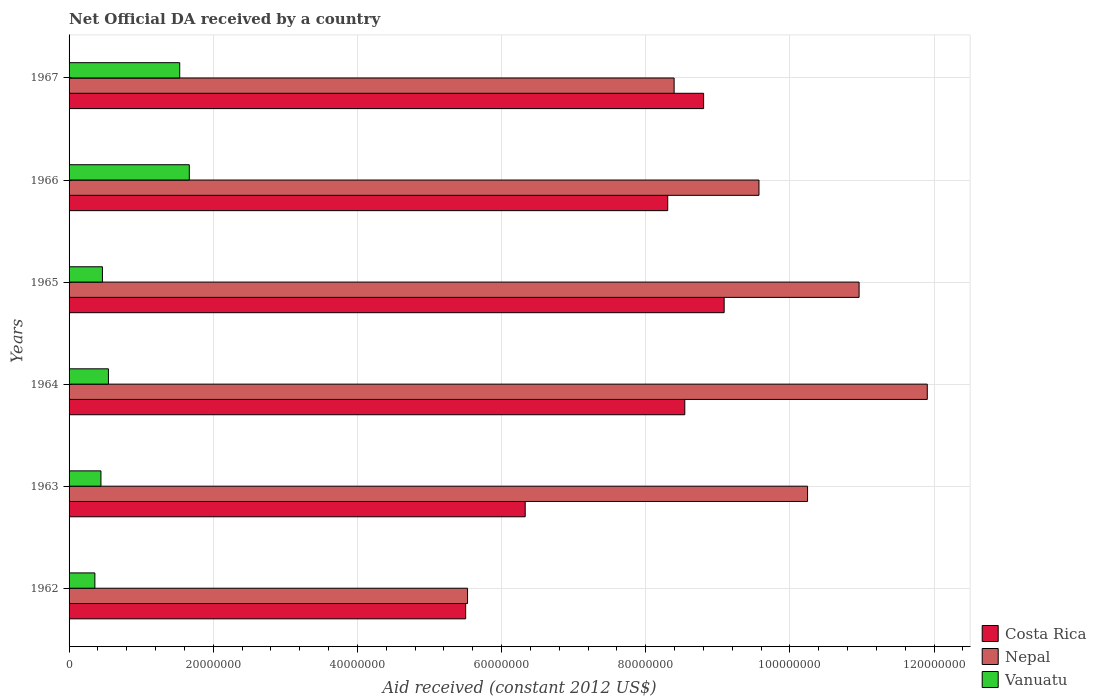How many groups of bars are there?
Your answer should be very brief. 6. What is the label of the 2nd group of bars from the top?
Offer a terse response. 1966. What is the net official development assistance aid received in Nepal in 1964?
Your response must be concise. 1.19e+08. Across all years, what is the maximum net official development assistance aid received in Nepal?
Provide a short and direct response. 1.19e+08. Across all years, what is the minimum net official development assistance aid received in Vanuatu?
Provide a succinct answer. 3.58e+06. In which year was the net official development assistance aid received in Nepal maximum?
Keep it short and to the point. 1964. In which year was the net official development assistance aid received in Nepal minimum?
Your response must be concise. 1962. What is the total net official development assistance aid received in Vanuatu in the graph?
Provide a short and direct response. 5.01e+07. What is the difference between the net official development assistance aid received in Costa Rica in 1964 and that in 1966?
Provide a succinct answer. 2.37e+06. What is the difference between the net official development assistance aid received in Nepal in 1962 and the net official development assistance aid received in Costa Rica in 1963?
Keep it short and to the point. -8.00e+06. What is the average net official development assistance aid received in Nepal per year?
Provide a succinct answer. 9.43e+07. In the year 1964, what is the difference between the net official development assistance aid received in Nepal and net official development assistance aid received in Vanuatu?
Offer a terse response. 1.14e+08. What is the ratio of the net official development assistance aid received in Nepal in 1962 to that in 1964?
Provide a succinct answer. 0.46. What is the difference between the highest and the second highest net official development assistance aid received in Vanuatu?
Provide a short and direct response. 1.33e+06. What is the difference between the highest and the lowest net official development assistance aid received in Nepal?
Your answer should be very brief. 6.38e+07. In how many years, is the net official development assistance aid received in Vanuatu greater than the average net official development assistance aid received in Vanuatu taken over all years?
Your answer should be compact. 2. What does the 3rd bar from the top in 1962 represents?
Your answer should be compact. Costa Rica. What does the 2nd bar from the bottom in 1965 represents?
Ensure brevity in your answer.  Nepal. Is it the case that in every year, the sum of the net official development assistance aid received in Vanuatu and net official development assistance aid received in Nepal is greater than the net official development assistance aid received in Costa Rica?
Provide a short and direct response. Yes. How many bars are there?
Ensure brevity in your answer.  18. Are the values on the major ticks of X-axis written in scientific E-notation?
Provide a succinct answer. No. Where does the legend appear in the graph?
Keep it short and to the point. Bottom right. How are the legend labels stacked?
Your answer should be very brief. Vertical. What is the title of the graph?
Offer a terse response. Net Official DA received by a country. What is the label or title of the X-axis?
Give a very brief answer. Aid received (constant 2012 US$). What is the label or title of the Y-axis?
Offer a terse response. Years. What is the Aid received (constant 2012 US$) in Costa Rica in 1962?
Offer a terse response. 5.50e+07. What is the Aid received (constant 2012 US$) in Nepal in 1962?
Your response must be concise. 5.53e+07. What is the Aid received (constant 2012 US$) in Vanuatu in 1962?
Your answer should be compact. 3.58e+06. What is the Aid received (constant 2012 US$) in Costa Rica in 1963?
Your answer should be compact. 6.33e+07. What is the Aid received (constant 2012 US$) of Nepal in 1963?
Provide a succinct answer. 1.02e+08. What is the Aid received (constant 2012 US$) of Vanuatu in 1963?
Keep it short and to the point. 4.42e+06. What is the Aid received (constant 2012 US$) in Costa Rica in 1964?
Keep it short and to the point. 8.54e+07. What is the Aid received (constant 2012 US$) in Nepal in 1964?
Keep it short and to the point. 1.19e+08. What is the Aid received (constant 2012 US$) of Vanuatu in 1964?
Make the answer very short. 5.46e+06. What is the Aid received (constant 2012 US$) in Costa Rica in 1965?
Ensure brevity in your answer.  9.09e+07. What is the Aid received (constant 2012 US$) of Nepal in 1965?
Keep it short and to the point. 1.10e+08. What is the Aid received (constant 2012 US$) in Vanuatu in 1965?
Offer a terse response. 4.63e+06. What is the Aid received (constant 2012 US$) in Costa Rica in 1966?
Make the answer very short. 8.30e+07. What is the Aid received (constant 2012 US$) of Nepal in 1966?
Offer a terse response. 9.57e+07. What is the Aid received (constant 2012 US$) in Vanuatu in 1966?
Offer a very short reply. 1.67e+07. What is the Aid received (constant 2012 US$) in Costa Rica in 1967?
Your answer should be compact. 8.80e+07. What is the Aid received (constant 2012 US$) in Nepal in 1967?
Offer a very short reply. 8.39e+07. What is the Aid received (constant 2012 US$) of Vanuatu in 1967?
Provide a succinct answer. 1.54e+07. Across all years, what is the maximum Aid received (constant 2012 US$) in Costa Rica?
Your response must be concise. 9.09e+07. Across all years, what is the maximum Aid received (constant 2012 US$) in Nepal?
Offer a very short reply. 1.19e+08. Across all years, what is the maximum Aid received (constant 2012 US$) of Vanuatu?
Offer a terse response. 1.67e+07. Across all years, what is the minimum Aid received (constant 2012 US$) of Costa Rica?
Provide a short and direct response. 5.50e+07. Across all years, what is the minimum Aid received (constant 2012 US$) in Nepal?
Give a very brief answer. 5.53e+07. Across all years, what is the minimum Aid received (constant 2012 US$) in Vanuatu?
Ensure brevity in your answer.  3.58e+06. What is the total Aid received (constant 2012 US$) of Costa Rica in the graph?
Give a very brief answer. 4.66e+08. What is the total Aid received (constant 2012 US$) of Nepal in the graph?
Provide a succinct answer. 5.66e+08. What is the total Aid received (constant 2012 US$) of Vanuatu in the graph?
Your response must be concise. 5.01e+07. What is the difference between the Aid received (constant 2012 US$) in Costa Rica in 1962 and that in 1963?
Make the answer very short. -8.26e+06. What is the difference between the Aid received (constant 2012 US$) in Nepal in 1962 and that in 1963?
Provide a short and direct response. -4.72e+07. What is the difference between the Aid received (constant 2012 US$) of Vanuatu in 1962 and that in 1963?
Your response must be concise. -8.40e+05. What is the difference between the Aid received (constant 2012 US$) of Costa Rica in 1962 and that in 1964?
Keep it short and to the point. -3.04e+07. What is the difference between the Aid received (constant 2012 US$) in Nepal in 1962 and that in 1964?
Your answer should be very brief. -6.38e+07. What is the difference between the Aid received (constant 2012 US$) of Vanuatu in 1962 and that in 1964?
Your answer should be very brief. -1.88e+06. What is the difference between the Aid received (constant 2012 US$) of Costa Rica in 1962 and that in 1965?
Keep it short and to the point. -3.59e+07. What is the difference between the Aid received (constant 2012 US$) of Nepal in 1962 and that in 1965?
Ensure brevity in your answer.  -5.43e+07. What is the difference between the Aid received (constant 2012 US$) in Vanuatu in 1962 and that in 1965?
Give a very brief answer. -1.05e+06. What is the difference between the Aid received (constant 2012 US$) in Costa Rica in 1962 and that in 1966?
Your answer should be very brief. -2.80e+07. What is the difference between the Aid received (constant 2012 US$) in Nepal in 1962 and that in 1966?
Ensure brevity in your answer.  -4.04e+07. What is the difference between the Aid received (constant 2012 US$) of Vanuatu in 1962 and that in 1966?
Offer a very short reply. -1.31e+07. What is the difference between the Aid received (constant 2012 US$) in Costa Rica in 1962 and that in 1967?
Your answer should be compact. -3.30e+07. What is the difference between the Aid received (constant 2012 US$) in Nepal in 1962 and that in 1967?
Your answer should be compact. -2.87e+07. What is the difference between the Aid received (constant 2012 US$) in Vanuatu in 1962 and that in 1967?
Provide a succinct answer. -1.18e+07. What is the difference between the Aid received (constant 2012 US$) in Costa Rica in 1963 and that in 1964?
Your response must be concise. -2.21e+07. What is the difference between the Aid received (constant 2012 US$) in Nepal in 1963 and that in 1964?
Provide a succinct answer. -1.66e+07. What is the difference between the Aid received (constant 2012 US$) in Vanuatu in 1963 and that in 1964?
Offer a very short reply. -1.04e+06. What is the difference between the Aid received (constant 2012 US$) of Costa Rica in 1963 and that in 1965?
Give a very brief answer. -2.76e+07. What is the difference between the Aid received (constant 2012 US$) in Nepal in 1963 and that in 1965?
Offer a very short reply. -7.15e+06. What is the difference between the Aid received (constant 2012 US$) of Costa Rica in 1963 and that in 1966?
Your answer should be compact. -1.98e+07. What is the difference between the Aid received (constant 2012 US$) of Nepal in 1963 and that in 1966?
Make the answer very short. 6.74e+06. What is the difference between the Aid received (constant 2012 US$) of Vanuatu in 1963 and that in 1966?
Make the answer very short. -1.23e+07. What is the difference between the Aid received (constant 2012 US$) of Costa Rica in 1963 and that in 1967?
Give a very brief answer. -2.48e+07. What is the difference between the Aid received (constant 2012 US$) of Nepal in 1963 and that in 1967?
Your answer should be compact. 1.85e+07. What is the difference between the Aid received (constant 2012 US$) of Vanuatu in 1963 and that in 1967?
Your answer should be very brief. -1.09e+07. What is the difference between the Aid received (constant 2012 US$) in Costa Rica in 1964 and that in 1965?
Ensure brevity in your answer.  -5.46e+06. What is the difference between the Aid received (constant 2012 US$) of Nepal in 1964 and that in 1965?
Your answer should be compact. 9.46e+06. What is the difference between the Aid received (constant 2012 US$) of Vanuatu in 1964 and that in 1965?
Ensure brevity in your answer.  8.30e+05. What is the difference between the Aid received (constant 2012 US$) of Costa Rica in 1964 and that in 1966?
Offer a terse response. 2.37e+06. What is the difference between the Aid received (constant 2012 US$) in Nepal in 1964 and that in 1966?
Make the answer very short. 2.34e+07. What is the difference between the Aid received (constant 2012 US$) in Vanuatu in 1964 and that in 1966?
Your answer should be very brief. -1.12e+07. What is the difference between the Aid received (constant 2012 US$) of Costa Rica in 1964 and that in 1967?
Your response must be concise. -2.61e+06. What is the difference between the Aid received (constant 2012 US$) of Nepal in 1964 and that in 1967?
Give a very brief answer. 3.51e+07. What is the difference between the Aid received (constant 2012 US$) of Vanuatu in 1964 and that in 1967?
Make the answer very short. -9.89e+06. What is the difference between the Aid received (constant 2012 US$) of Costa Rica in 1965 and that in 1966?
Give a very brief answer. 7.83e+06. What is the difference between the Aid received (constant 2012 US$) of Nepal in 1965 and that in 1966?
Your answer should be compact. 1.39e+07. What is the difference between the Aid received (constant 2012 US$) in Vanuatu in 1965 and that in 1966?
Provide a short and direct response. -1.20e+07. What is the difference between the Aid received (constant 2012 US$) in Costa Rica in 1965 and that in 1967?
Ensure brevity in your answer.  2.85e+06. What is the difference between the Aid received (constant 2012 US$) of Nepal in 1965 and that in 1967?
Your response must be concise. 2.57e+07. What is the difference between the Aid received (constant 2012 US$) in Vanuatu in 1965 and that in 1967?
Provide a short and direct response. -1.07e+07. What is the difference between the Aid received (constant 2012 US$) of Costa Rica in 1966 and that in 1967?
Offer a very short reply. -4.98e+06. What is the difference between the Aid received (constant 2012 US$) in Nepal in 1966 and that in 1967?
Your answer should be compact. 1.18e+07. What is the difference between the Aid received (constant 2012 US$) in Vanuatu in 1966 and that in 1967?
Make the answer very short. 1.33e+06. What is the difference between the Aid received (constant 2012 US$) in Costa Rica in 1962 and the Aid received (constant 2012 US$) in Nepal in 1963?
Ensure brevity in your answer.  -4.74e+07. What is the difference between the Aid received (constant 2012 US$) of Costa Rica in 1962 and the Aid received (constant 2012 US$) of Vanuatu in 1963?
Your answer should be very brief. 5.06e+07. What is the difference between the Aid received (constant 2012 US$) of Nepal in 1962 and the Aid received (constant 2012 US$) of Vanuatu in 1963?
Offer a terse response. 5.09e+07. What is the difference between the Aid received (constant 2012 US$) in Costa Rica in 1962 and the Aid received (constant 2012 US$) in Nepal in 1964?
Offer a very short reply. -6.40e+07. What is the difference between the Aid received (constant 2012 US$) in Costa Rica in 1962 and the Aid received (constant 2012 US$) in Vanuatu in 1964?
Ensure brevity in your answer.  4.96e+07. What is the difference between the Aid received (constant 2012 US$) of Nepal in 1962 and the Aid received (constant 2012 US$) of Vanuatu in 1964?
Make the answer very short. 4.98e+07. What is the difference between the Aid received (constant 2012 US$) in Costa Rica in 1962 and the Aid received (constant 2012 US$) in Nepal in 1965?
Offer a very short reply. -5.46e+07. What is the difference between the Aid received (constant 2012 US$) of Costa Rica in 1962 and the Aid received (constant 2012 US$) of Vanuatu in 1965?
Give a very brief answer. 5.04e+07. What is the difference between the Aid received (constant 2012 US$) in Nepal in 1962 and the Aid received (constant 2012 US$) in Vanuatu in 1965?
Give a very brief answer. 5.06e+07. What is the difference between the Aid received (constant 2012 US$) in Costa Rica in 1962 and the Aid received (constant 2012 US$) in Nepal in 1966?
Offer a terse response. -4.07e+07. What is the difference between the Aid received (constant 2012 US$) in Costa Rica in 1962 and the Aid received (constant 2012 US$) in Vanuatu in 1966?
Give a very brief answer. 3.83e+07. What is the difference between the Aid received (constant 2012 US$) of Nepal in 1962 and the Aid received (constant 2012 US$) of Vanuatu in 1966?
Ensure brevity in your answer.  3.86e+07. What is the difference between the Aid received (constant 2012 US$) in Costa Rica in 1962 and the Aid received (constant 2012 US$) in Nepal in 1967?
Keep it short and to the point. -2.89e+07. What is the difference between the Aid received (constant 2012 US$) of Costa Rica in 1962 and the Aid received (constant 2012 US$) of Vanuatu in 1967?
Offer a very short reply. 3.97e+07. What is the difference between the Aid received (constant 2012 US$) of Nepal in 1962 and the Aid received (constant 2012 US$) of Vanuatu in 1967?
Your response must be concise. 3.99e+07. What is the difference between the Aid received (constant 2012 US$) in Costa Rica in 1963 and the Aid received (constant 2012 US$) in Nepal in 1964?
Your answer should be compact. -5.58e+07. What is the difference between the Aid received (constant 2012 US$) in Costa Rica in 1963 and the Aid received (constant 2012 US$) in Vanuatu in 1964?
Your response must be concise. 5.78e+07. What is the difference between the Aid received (constant 2012 US$) of Nepal in 1963 and the Aid received (constant 2012 US$) of Vanuatu in 1964?
Provide a succinct answer. 9.70e+07. What is the difference between the Aid received (constant 2012 US$) of Costa Rica in 1963 and the Aid received (constant 2012 US$) of Nepal in 1965?
Your answer should be compact. -4.63e+07. What is the difference between the Aid received (constant 2012 US$) in Costa Rica in 1963 and the Aid received (constant 2012 US$) in Vanuatu in 1965?
Ensure brevity in your answer.  5.86e+07. What is the difference between the Aid received (constant 2012 US$) in Nepal in 1963 and the Aid received (constant 2012 US$) in Vanuatu in 1965?
Make the answer very short. 9.78e+07. What is the difference between the Aid received (constant 2012 US$) of Costa Rica in 1963 and the Aid received (constant 2012 US$) of Nepal in 1966?
Ensure brevity in your answer.  -3.24e+07. What is the difference between the Aid received (constant 2012 US$) in Costa Rica in 1963 and the Aid received (constant 2012 US$) in Vanuatu in 1966?
Ensure brevity in your answer.  4.66e+07. What is the difference between the Aid received (constant 2012 US$) in Nepal in 1963 and the Aid received (constant 2012 US$) in Vanuatu in 1966?
Give a very brief answer. 8.58e+07. What is the difference between the Aid received (constant 2012 US$) in Costa Rica in 1963 and the Aid received (constant 2012 US$) in Nepal in 1967?
Keep it short and to the point. -2.07e+07. What is the difference between the Aid received (constant 2012 US$) in Costa Rica in 1963 and the Aid received (constant 2012 US$) in Vanuatu in 1967?
Provide a succinct answer. 4.79e+07. What is the difference between the Aid received (constant 2012 US$) of Nepal in 1963 and the Aid received (constant 2012 US$) of Vanuatu in 1967?
Your answer should be very brief. 8.71e+07. What is the difference between the Aid received (constant 2012 US$) of Costa Rica in 1964 and the Aid received (constant 2012 US$) of Nepal in 1965?
Provide a succinct answer. -2.42e+07. What is the difference between the Aid received (constant 2012 US$) of Costa Rica in 1964 and the Aid received (constant 2012 US$) of Vanuatu in 1965?
Provide a succinct answer. 8.08e+07. What is the difference between the Aid received (constant 2012 US$) of Nepal in 1964 and the Aid received (constant 2012 US$) of Vanuatu in 1965?
Offer a very short reply. 1.14e+08. What is the difference between the Aid received (constant 2012 US$) of Costa Rica in 1964 and the Aid received (constant 2012 US$) of Nepal in 1966?
Give a very brief answer. -1.03e+07. What is the difference between the Aid received (constant 2012 US$) of Costa Rica in 1964 and the Aid received (constant 2012 US$) of Vanuatu in 1966?
Make the answer very short. 6.87e+07. What is the difference between the Aid received (constant 2012 US$) in Nepal in 1964 and the Aid received (constant 2012 US$) in Vanuatu in 1966?
Provide a succinct answer. 1.02e+08. What is the difference between the Aid received (constant 2012 US$) of Costa Rica in 1964 and the Aid received (constant 2012 US$) of Nepal in 1967?
Offer a very short reply. 1.48e+06. What is the difference between the Aid received (constant 2012 US$) of Costa Rica in 1964 and the Aid received (constant 2012 US$) of Vanuatu in 1967?
Provide a succinct answer. 7.01e+07. What is the difference between the Aid received (constant 2012 US$) of Nepal in 1964 and the Aid received (constant 2012 US$) of Vanuatu in 1967?
Keep it short and to the point. 1.04e+08. What is the difference between the Aid received (constant 2012 US$) of Costa Rica in 1965 and the Aid received (constant 2012 US$) of Nepal in 1966?
Offer a very short reply. -4.83e+06. What is the difference between the Aid received (constant 2012 US$) of Costa Rica in 1965 and the Aid received (constant 2012 US$) of Vanuatu in 1966?
Make the answer very short. 7.42e+07. What is the difference between the Aid received (constant 2012 US$) of Nepal in 1965 and the Aid received (constant 2012 US$) of Vanuatu in 1966?
Offer a very short reply. 9.29e+07. What is the difference between the Aid received (constant 2012 US$) in Costa Rica in 1965 and the Aid received (constant 2012 US$) in Nepal in 1967?
Provide a succinct answer. 6.94e+06. What is the difference between the Aid received (constant 2012 US$) in Costa Rica in 1965 and the Aid received (constant 2012 US$) in Vanuatu in 1967?
Offer a terse response. 7.55e+07. What is the difference between the Aid received (constant 2012 US$) in Nepal in 1965 and the Aid received (constant 2012 US$) in Vanuatu in 1967?
Offer a terse response. 9.42e+07. What is the difference between the Aid received (constant 2012 US$) of Costa Rica in 1966 and the Aid received (constant 2012 US$) of Nepal in 1967?
Provide a short and direct response. -8.90e+05. What is the difference between the Aid received (constant 2012 US$) in Costa Rica in 1966 and the Aid received (constant 2012 US$) in Vanuatu in 1967?
Your response must be concise. 6.77e+07. What is the difference between the Aid received (constant 2012 US$) in Nepal in 1966 and the Aid received (constant 2012 US$) in Vanuatu in 1967?
Make the answer very short. 8.04e+07. What is the average Aid received (constant 2012 US$) of Costa Rica per year?
Offer a terse response. 7.76e+07. What is the average Aid received (constant 2012 US$) of Nepal per year?
Provide a succinct answer. 9.43e+07. What is the average Aid received (constant 2012 US$) in Vanuatu per year?
Provide a succinct answer. 8.35e+06. In the year 1962, what is the difference between the Aid received (constant 2012 US$) in Costa Rica and Aid received (constant 2012 US$) in Vanuatu?
Your answer should be compact. 5.14e+07. In the year 1962, what is the difference between the Aid received (constant 2012 US$) in Nepal and Aid received (constant 2012 US$) in Vanuatu?
Keep it short and to the point. 5.17e+07. In the year 1963, what is the difference between the Aid received (constant 2012 US$) of Costa Rica and Aid received (constant 2012 US$) of Nepal?
Make the answer very short. -3.92e+07. In the year 1963, what is the difference between the Aid received (constant 2012 US$) of Costa Rica and Aid received (constant 2012 US$) of Vanuatu?
Offer a very short reply. 5.89e+07. In the year 1963, what is the difference between the Aid received (constant 2012 US$) of Nepal and Aid received (constant 2012 US$) of Vanuatu?
Offer a very short reply. 9.80e+07. In the year 1964, what is the difference between the Aid received (constant 2012 US$) in Costa Rica and Aid received (constant 2012 US$) in Nepal?
Make the answer very short. -3.36e+07. In the year 1964, what is the difference between the Aid received (constant 2012 US$) in Costa Rica and Aid received (constant 2012 US$) in Vanuatu?
Give a very brief answer. 8.00e+07. In the year 1964, what is the difference between the Aid received (constant 2012 US$) of Nepal and Aid received (constant 2012 US$) of Vanuatu?
Keep it short and to the point. 1.14e+08. In the year 1965, what is the difference between the Aid received (constant 2012 US$) in Costa Rica and Aid received (constant 2012 US$) in Nepal?
Provide a short and direct response. -1.87e+07. In the year 1965, what is the difference between the Aid received (constant 2012 US$) of Costa Rica and Aid received (constant 2012 US$) of Vanuatu?
Make the answer very short. 8.62e+07. In the year 1965, what is the difference between the Aid received (constant 2012 US$) in Nepal and Aid received (constant 2012 US$) in Vanuatu?
Keep it short and to the point. 1.05e+08. In the year 1966, what is the difference between the Aid received (constant 2012 US$) of Costa Rica and Aid received (constant 2012 US$) of Nepal?
Your answer should be compact. -1.27e+07. In the year 1966, what is the difference between the Aid received (constant 2012 US$) of Costa Rica and Aid received (constant 2012 US$) of Vanuatu?
Ensure brevity in your answer.  6.64e+07. In the year 1966, what is the difference between the Aid received (constant 2012 US$) in Nepal and Aid received (constant 2012 US$) in Vanuatu?
Your answer should be very brief. 7.90e+07. In the year 1967, what is the difference between the Aid received (constant 2012 US$) of Costa Rica and Aid received (constant 2012 US$) of Nepal?
Keep it short and to the point. 4.09e+06. In the year 1967, what is the difference between the Aid received (constant 2012 US$) of Costa Rica and Aid received (constant 2012 US$) of Vanuatu?
Your answer should be very brief. 7.27e+07. In the year 1967, what is the difference between the Aid received (constant 2012 US$) in Nepal and Aid received (constant 2012 US$) in Vanuatu?
Make the answer very short. 6.86e+07. What is the ratio of the Aid received (constant 2012 US$) of Costa Rica in 1962 to that in 1963?
Keep it short and to the point. 0.87. What is the ratio of the Aid received (constant 2012 US$) in Nepal in 1962 to that in 1963?
Ensure brevity in your answer.  0.54. What is the ratio of the Aid received (constant 2012 US$) in Vanuatu in 1962 to that in 1963?
Provide a short and direct response. 0.81. What is the ratio of the Aid received (constant 2012 US$) of Costa Rica in 1962 to that in 1964?
Your answer should be compact. 0.64. What is the ratio of the Aid received (constant 2012 US$) of Nepal in 1962 to that in 1964?
Your answer should be compact. 0.46. What is the ratio of the Aid received (constant 2012 US$) of Vanuatu in 1962 to that in 1964?
Provide a succinct answer. 0.66. What is the ratio of the Aid received (constant 2012 US$) of Costa Rica in 1962 to that in 1965?
Provide a succinct answer. 0.61. What is the ratio of the Aid received (constant 2012 US$) of Nepal in 1962 to that in 1965?
Keep it short and to the point. 0.5. What is the ratio of the Aid received (constant 2012 US$) of Vanuatu in 1962 to that in 1965?
Ensure brevity in your answer.  0.77. What is the ratio of the Aid received (constant 2012 US$) in Costa Rica in 1962 to that in 1966?
Your answer should be very brief. 0.66. What is the ratio of the Aid received (constant 2012 US$) of Nepal in 1962 to that in 1966?
Offer a very short reply. 0.58. What is the ratio of the Aid received (constant 2012 US$) of Vanuatu in 1962 to that in 1966?
Provide a short and direct response. 0.21. What is the ratio of the Aid received (constant 2012 US$) of Nepal in 1962 to that in 1967?
Offer a very short reply. 0.66. What is the ratio of the Aid received (constant 2012 US$) in Vanuatu in 1962 to that in 1967?
Your answer should be compact. 0.23. What is the ratio of the Aid received (constant 2012 US$) of Costa Rica in 1963 to that in 1964?
Offer a terse response. 0.74. What is the ratio of the Aid received (constant 2012 US$) of Nepal in 1963 to that in 1964?
Provide a succinct answer. 0.86. What is the ratio of the Aid received (constant 2012 US$) of Vanuatu in 1963 to that in 1964?
Your answer should be very brief. 0.81. What is the ratio of the Aid received (constant 2012 US$) of Costa Rica in 1963 to that in 1965?
Ensure brevity in your answer.  0.7. What is the ratio of the Aid received (constant 2012 US$) in Nepal in 1963 to that in 1965?
Offer a very short reply. 0.93. What is the ratio of the Aid received (constant 2012 US$) of Vanuatu in 1963 to that in 1965?
Ensure brevity in your answer.  0.95. What is the ratio of the Aid received (constant 2012 US$) in Costa Rica in 1963 to that in 1966?
Your answer should be very brief. 0.76. What is the ratio of the Aid received (constant 2012 US$) of Nepal in 1963 to that in 1966?
Offer a terse response. 1.07. What is the ratio of the Aid received (constant 2012 US$) of Vanuatu in 1963 to that in 1966?
Give a very brief answer. 0.27. What is the ratio of the Aid received (constant 2012 US$) of Costa Rica in 1963 to that in 1967?
Your answer should be compact. 0.72. What is the ratio of the Aid received (constant 2012 US$) in Nepal in 1963 to that in 1967?
Your response must be concise. 1.22. What is the ratio of the Aid received (constant 2012 US$) of Vanuatu in 1963 to that in 1967?
Provide a succinct answer. 0.29. What is the ratio of the Aid received (constant 2012 US$) of Costa Rica in 1964 to that in 1965?
Offer a terse response. 0.94. What is the ratio of the Aid received (constant 2012 US$) in Nepal in 1964 to that in 1965?
Give a very brief answer. 1.09. What is the ratio of the Aid received (constant 2012 US$) of Vanuatu in 1964 to that in 1965?
Make the answer very short. 1.18. What is the ratio of the Aid received (constant 2012 US$) of Costa Rica in 1964 to that in 1966?
Make the answer very short. 1.03. What is the ratio of the Aid received (constant 2012 US$) in Nepal in 1964 to that in 1966?
Your answer should be compact. 1.24. What is the ratio of the Aid received (constant 2012 US$) of Vanuatu in 1964 to that in 1966?
Give a very brief answer. 0.33. What is the ratio of the Aid received (constant 2012 US$) of Costa Rica in 1964 to that in 1967?
Offer a terse response. 0.97. What is the ratio of the Aid received (constant 2012 US$) of Nepal in 1964 to that in 1967?
Provide a succinct answer. 1.42. What is the ratio of the Aid received (constant 2012 US$) of Vanuatu in 1964 to that in 1967?
Your answer should be compact. 0.36. What is the ratio of the Aid received (constant 2012 US$) in Costa Rica in 1965 to that in 1966?
Provide a succinct answer. 1.09. What is the ratio of the Aid received (constant 2012 US$) in Nepal in 1965 to that in 1966?
Your answer should be compact. 1.15. What is the ratio of the Aid received (constant 2012 US$) of Vanuatu in 1965 to that in 1966?
Your response must be concise. 0.28. What is the ratio of the Aid received (constant 2012 US$) of Costa Rica in 1965 to that in 1967?
Offer a very short reply. 1.03. What is the ratio of the Aid received (constant 2012 US$) of Nepal in 1965 to that in 1967?
Make the answer very short. 1.31. What is the ratio of the Aid received (constant 2012 US$) in Vanuatu in 1965 to that in 1967?
Make the answer very short. 0.3. What is the ratio of the Aid received (constant 2012 US$) of Costa Rica in 1966 to that in 1967?
Ensure brevity in your answer.  0.94. What is the ratio of the Aid received (constant 2012 US$) of Nepal in 1966 to that in 1967?
Give a very brief answer. 1.14. What is the ratio of the Aid received (constant 2012 US$) of Vanuatu in 1966 to that in 1967?
Offer a very short reply. 1.09. What is the difference between the highest and the second highest Aid received (constant 2012 US$) in Costa Rica?
Provide a succinct answer. 2.85e+06. What is the difference between the highest and the second highest Aid received (constant 2012 US$) of Nepal?
Your answer should be very brief. 9.46e+06. What is the difference between the highest and the second highest Aid received (constant 2012 US$) in Vanuatu?
Make the answer very short. 1.33e+06. What is the difference between the highest and the lowest Aid received (constant 2012 US$) of Costa Rica?
Give a very brief answer. 3.59e+07. What is the difference between the highest and the lowest Aid received (constant 2012 US$) in Nepal?
Your answer should be compact. 6.38e+07. What is the difference between the highest and the lowest Aid received (constant 2012 US$) in Vanuatu?
Offer a terse response. 1.31e+07. 